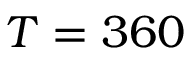Convert formula to latex. <formula><loc_0><loc_0><loc_500><loc_500>T = 3 6 0</formula> 